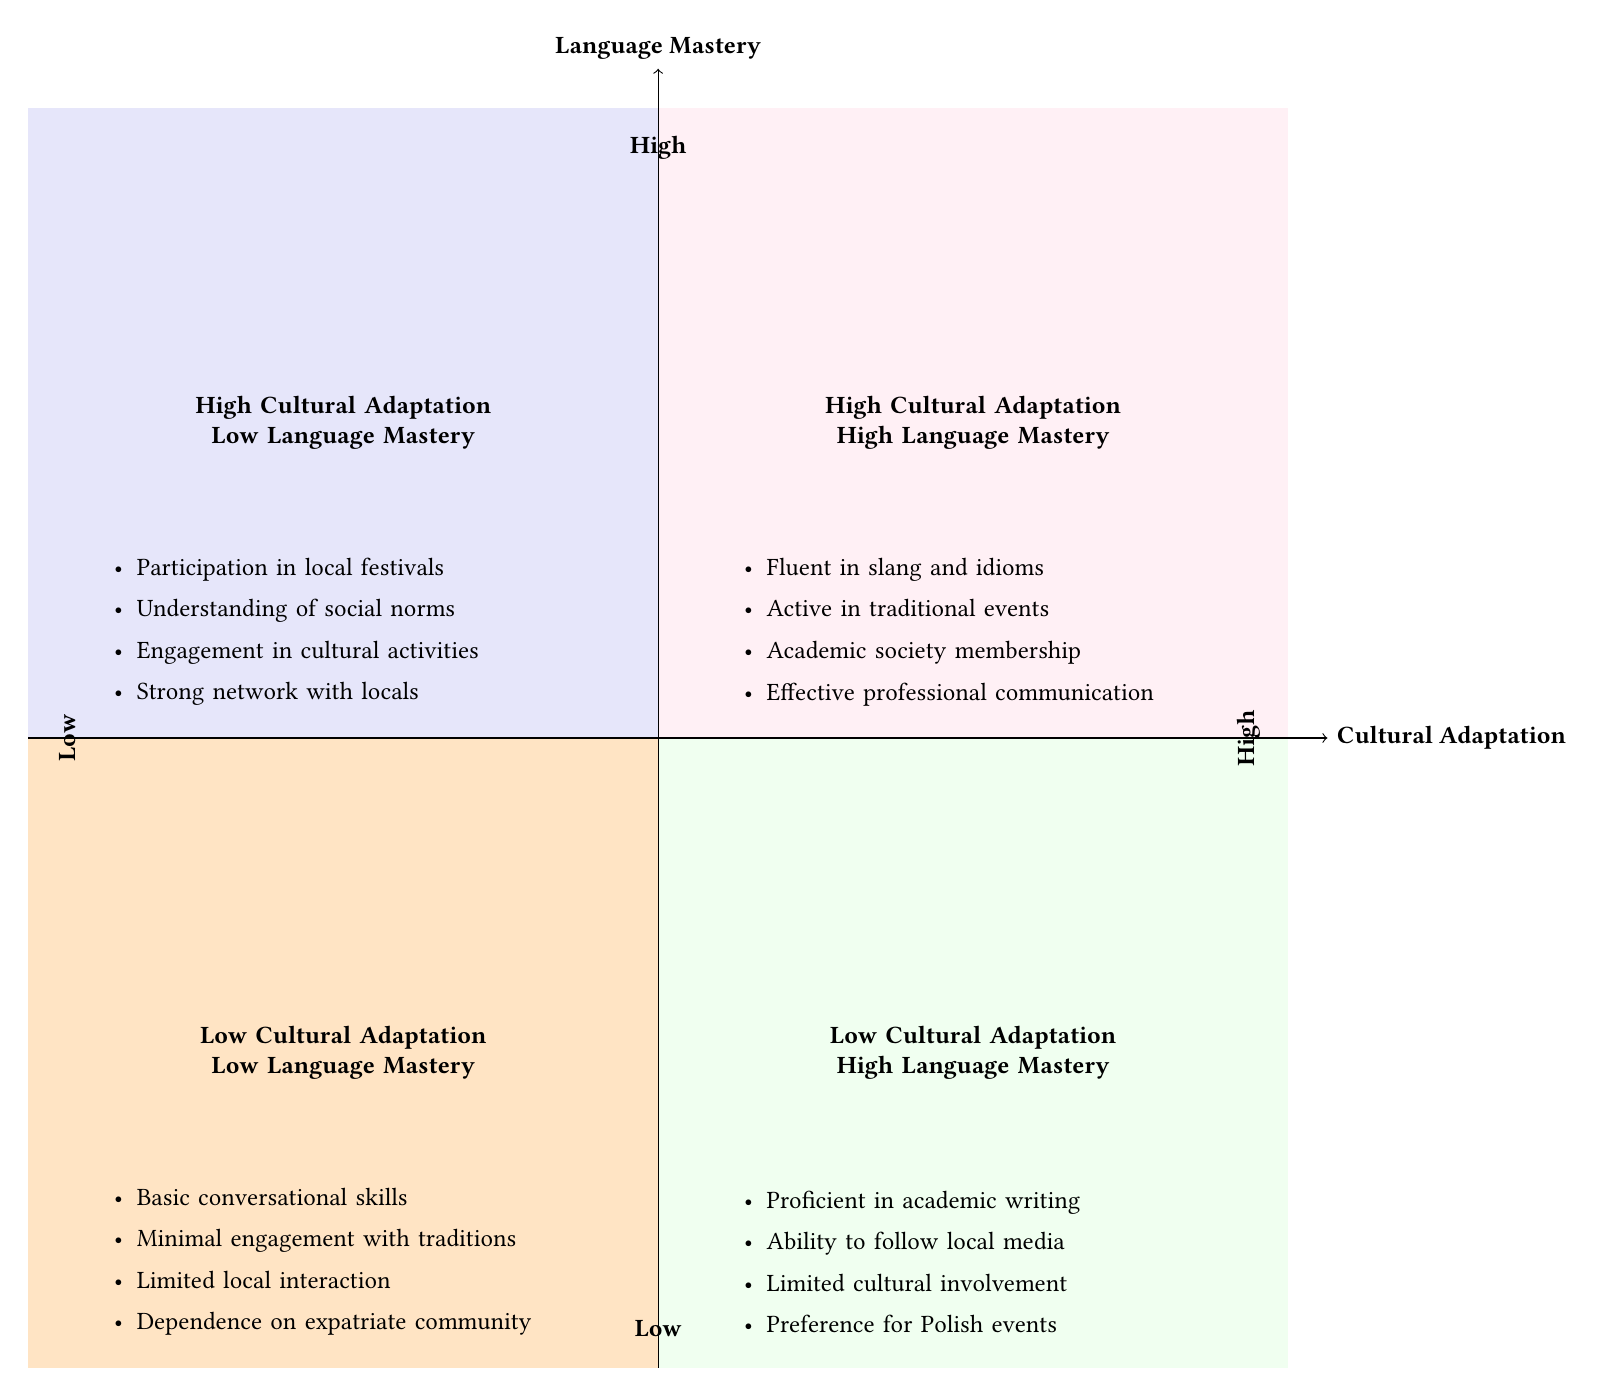What does the top-left quadrant represent? The top-left quadrant represents the combination of High Cultural Adaptation and Low Language Mastery, indicating individuals who participate in local festivals and understand social norms but have limited language skills.
Answer: High Cultural Adaptation - Low Language Mastery How many elements are in the High Cultural Adaptation - High Language Mastery quadrant? The High Cultural Adaptation - High Language Mastery quadrant contains four elements: fluent in slang and idioms, active in traditional events, academic society membership, and effective professional communication.
Answer: 4 What is listed as an element in the Low Cultural Adaptation - Low Language Mastery quadrant? One of the listed elements in this quadrant is "Basic conversational skills in Macedonian with heavy reliance on English."
Answer: Basic conversational skills in Macedonian Which quadrant has elements related to engagement in cultural activities? The elements related to engagement in cultural activities are presented in the High Cultural Adaptation - Low Language Mastery quadrant, where individuals are actively involved in local festivals and customs despite limited language proficiency.
Answer: High Cultural Adaptation - Low Language Mastery Can individuals in the Low Cultural Adaptation - High Language Mastery quadrant engage in Polish cultural events? Yes, individuals in the Low Cultural Adaptation - High Language Mastery quadrant show a preference for Polish cultural events, indicating they favor their own culture over local adaptations.
Answer: Yes Which quadrant would likely involve participation in Vevchani Carnival? Participation in Vevchani Carnival is a listed element of the High Cultural Adaptation - High Language Mastery quadrant, indicating active involvement in significant Macedonian cultural events.
Answer: High Cultural Adaptation - High Language Mastery What type of communication skills do individuals in the Low Cultural Adaptation - High Language Mastery quadrant possess? Individuals in this quadrant are proficient in reading and writing academic papers in both Polish and Macedonian, showcasing significant language skills but lacking cultural engagement.
Answer: Proficient in reading and writing academic papers How do the elements in the diagram contrast across the different quadrants? The quadrants contrast by showcasing varying levels of cultural adaptation and language mastery; for instance, one quadrant demonstrates high cultural involvement with limited language proficiency, while another contrasts with high language skills but low cultural involvement.
Answer: Varying levels of cultural adaptation and language mastery What is the significance of strong networks in the High Cultural Adaptation - Low Language Mastery quadrant? Strong networks in this quadrant indicate that individuals have built relationships with local Macedonians, enhancing their cultural adaptation despite language limitations.
Answer: Enhances cultural adaptation 